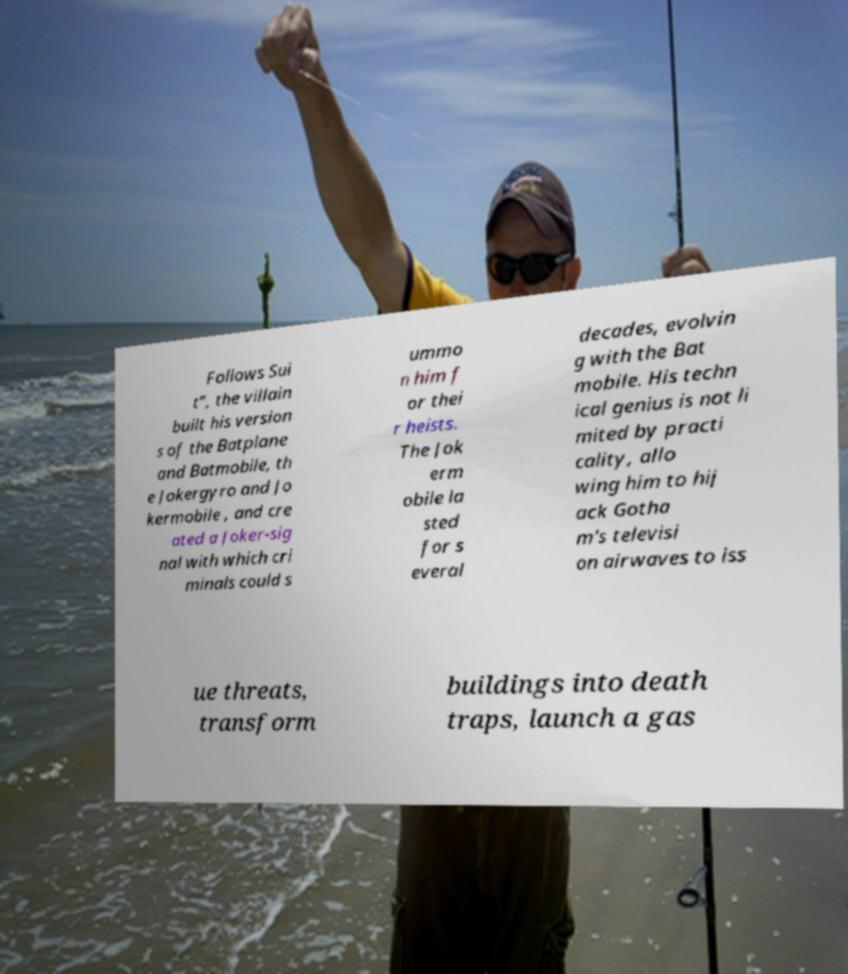Could you extract and type out the text from this image? Follows Sui t", the villain built his version s of the Batplane and Batmobile, th e Jokergyro and Jo kermobile , and cre ated a Joker-sig nal with which cri minals could s ummo n him f or thei r heists. The Jok erm obile la sted for s everal decades, evolvin g with the Bat mobile. His techn ical genius is not li mited by practi cality, allo wing him to hij ack Gotha m's televisi on airwaves to iss ue threats, transform buildings into death traps, launch a gas 